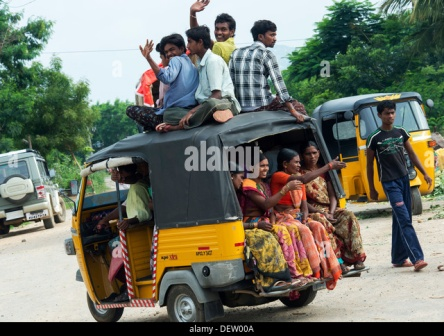What can you say about the surroundings and the overall environment in this image? The environment in the image seems to be a rural or suburban area, characterized by the presence of dirt roads and lush greenery in the backdrop. Trees and scattered patches of vegetation suggest a natural setting that contrasts with the vibrancy of human activity on the road. The overall atmosphere appears lively and communal, with people interacting cheerfully, which adds to the sense of a close-knit community enjoying a spontaneous moment together. 